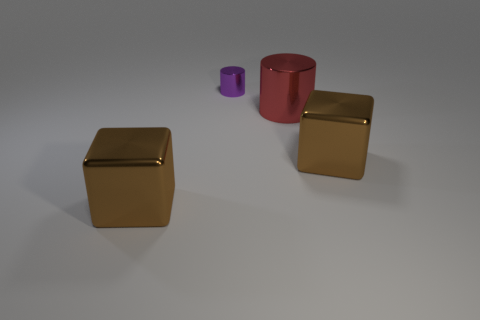Add 2 yellow matte cylinders. How many objects exist? 6 Subtract 0 red blocks. How many objects are left? 4 Subtract all tiny cylinders. Subtract all metal cubes. How many objects are left? 1 Add 3 large brown metallic things. How many large brown metallic things are left? 5 Add 3 large green metallic balls. How many large green metallic balls exist? 3 